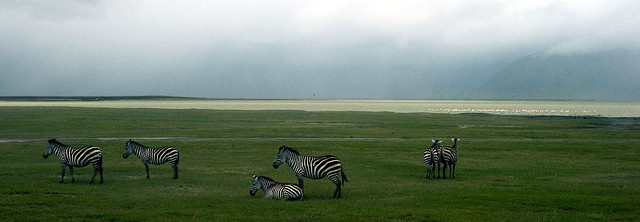Describe the objects in this image and their specific colors. I can see zebra in lightgray, black, gray, darkgreen, and darkgray tones, zebra in lightgray, black, gray, darkgreen, and teal tones, zebra in lightgray, black, gray, darkgreen, and teal tones, zebra in lightgray, black, gray, darkgreen, and darkgray tones, and zebra in lightgray, black, gray, and darkgreen tones in this image. 